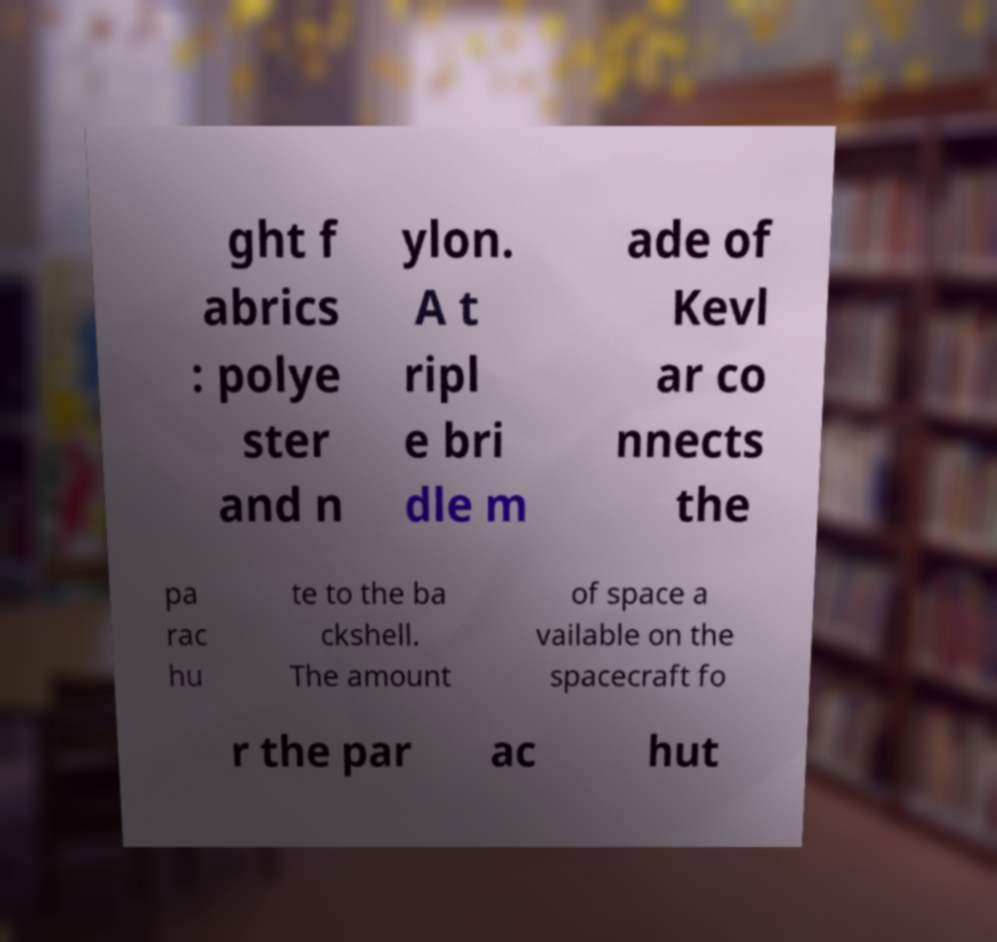What messages or text are displayed in this image? I need them in a readable, typed format. ght f abrics : polye ster and n ylon. A t ripl e bri dle m ade of Kevl ar co nnects the pa rac hu te to the ba ckshell. The amount of space a vailable on the spacecraft fo r the par ac hut 